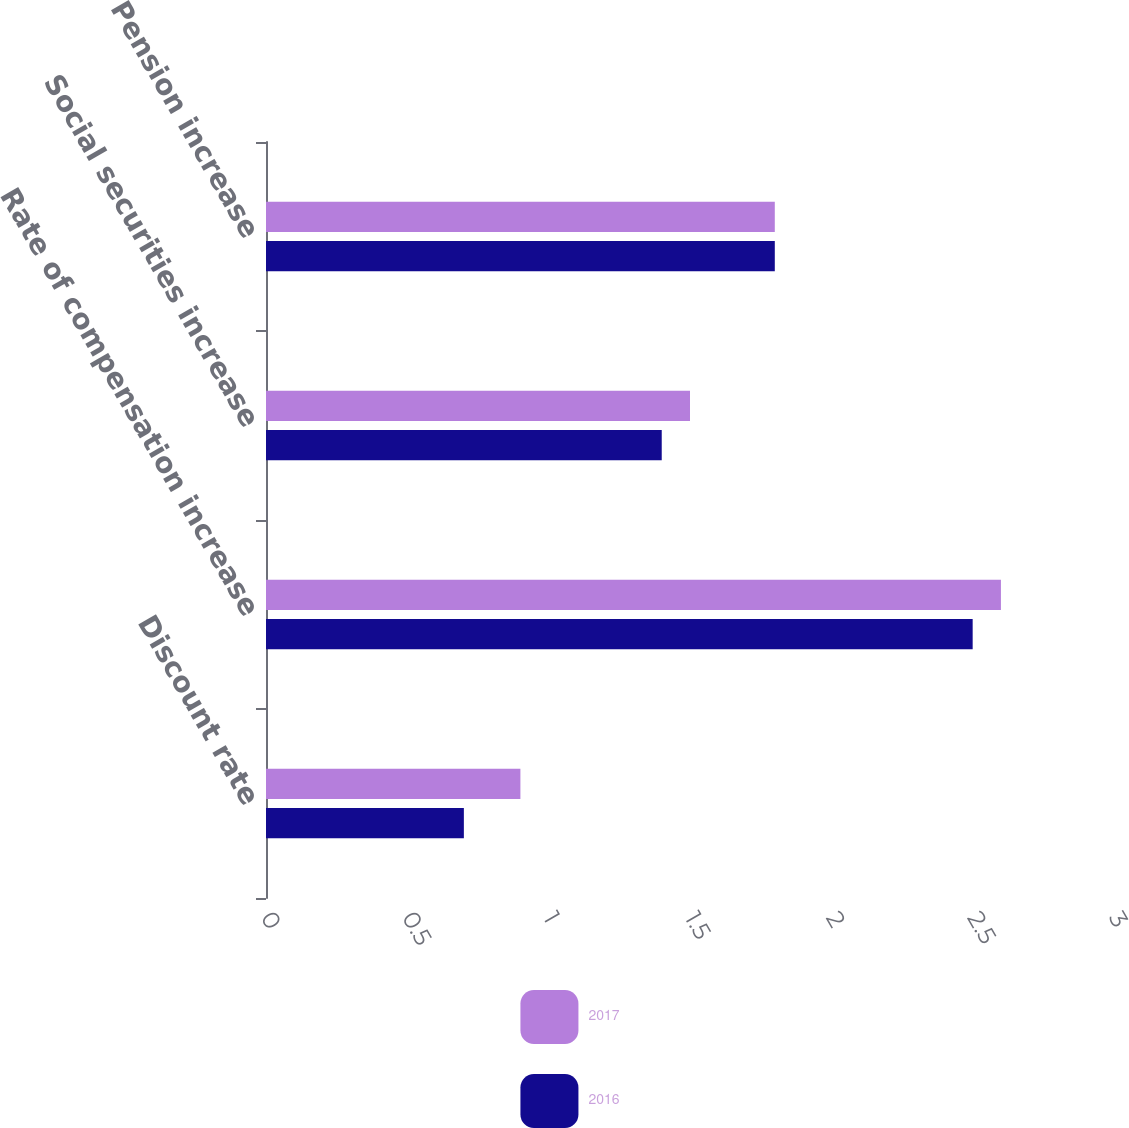Convert chart to OTSL. <chart><loc_0><loc_0><loc_500><loc_500><stacked_bar_chart><ecel><fcel>Discount rate<fcel>Rate of compensation increase<fcel>Social securities increase<fcel>Pension increase<nl><fcel>2017<fcel>0.9<fcel>2.6<fcel>1.5<fcel>1.8<nl><fcel>2016<fcel>0.7<fcel>2.5<fcel>1.4<fcel>1.8<nl></chart> 